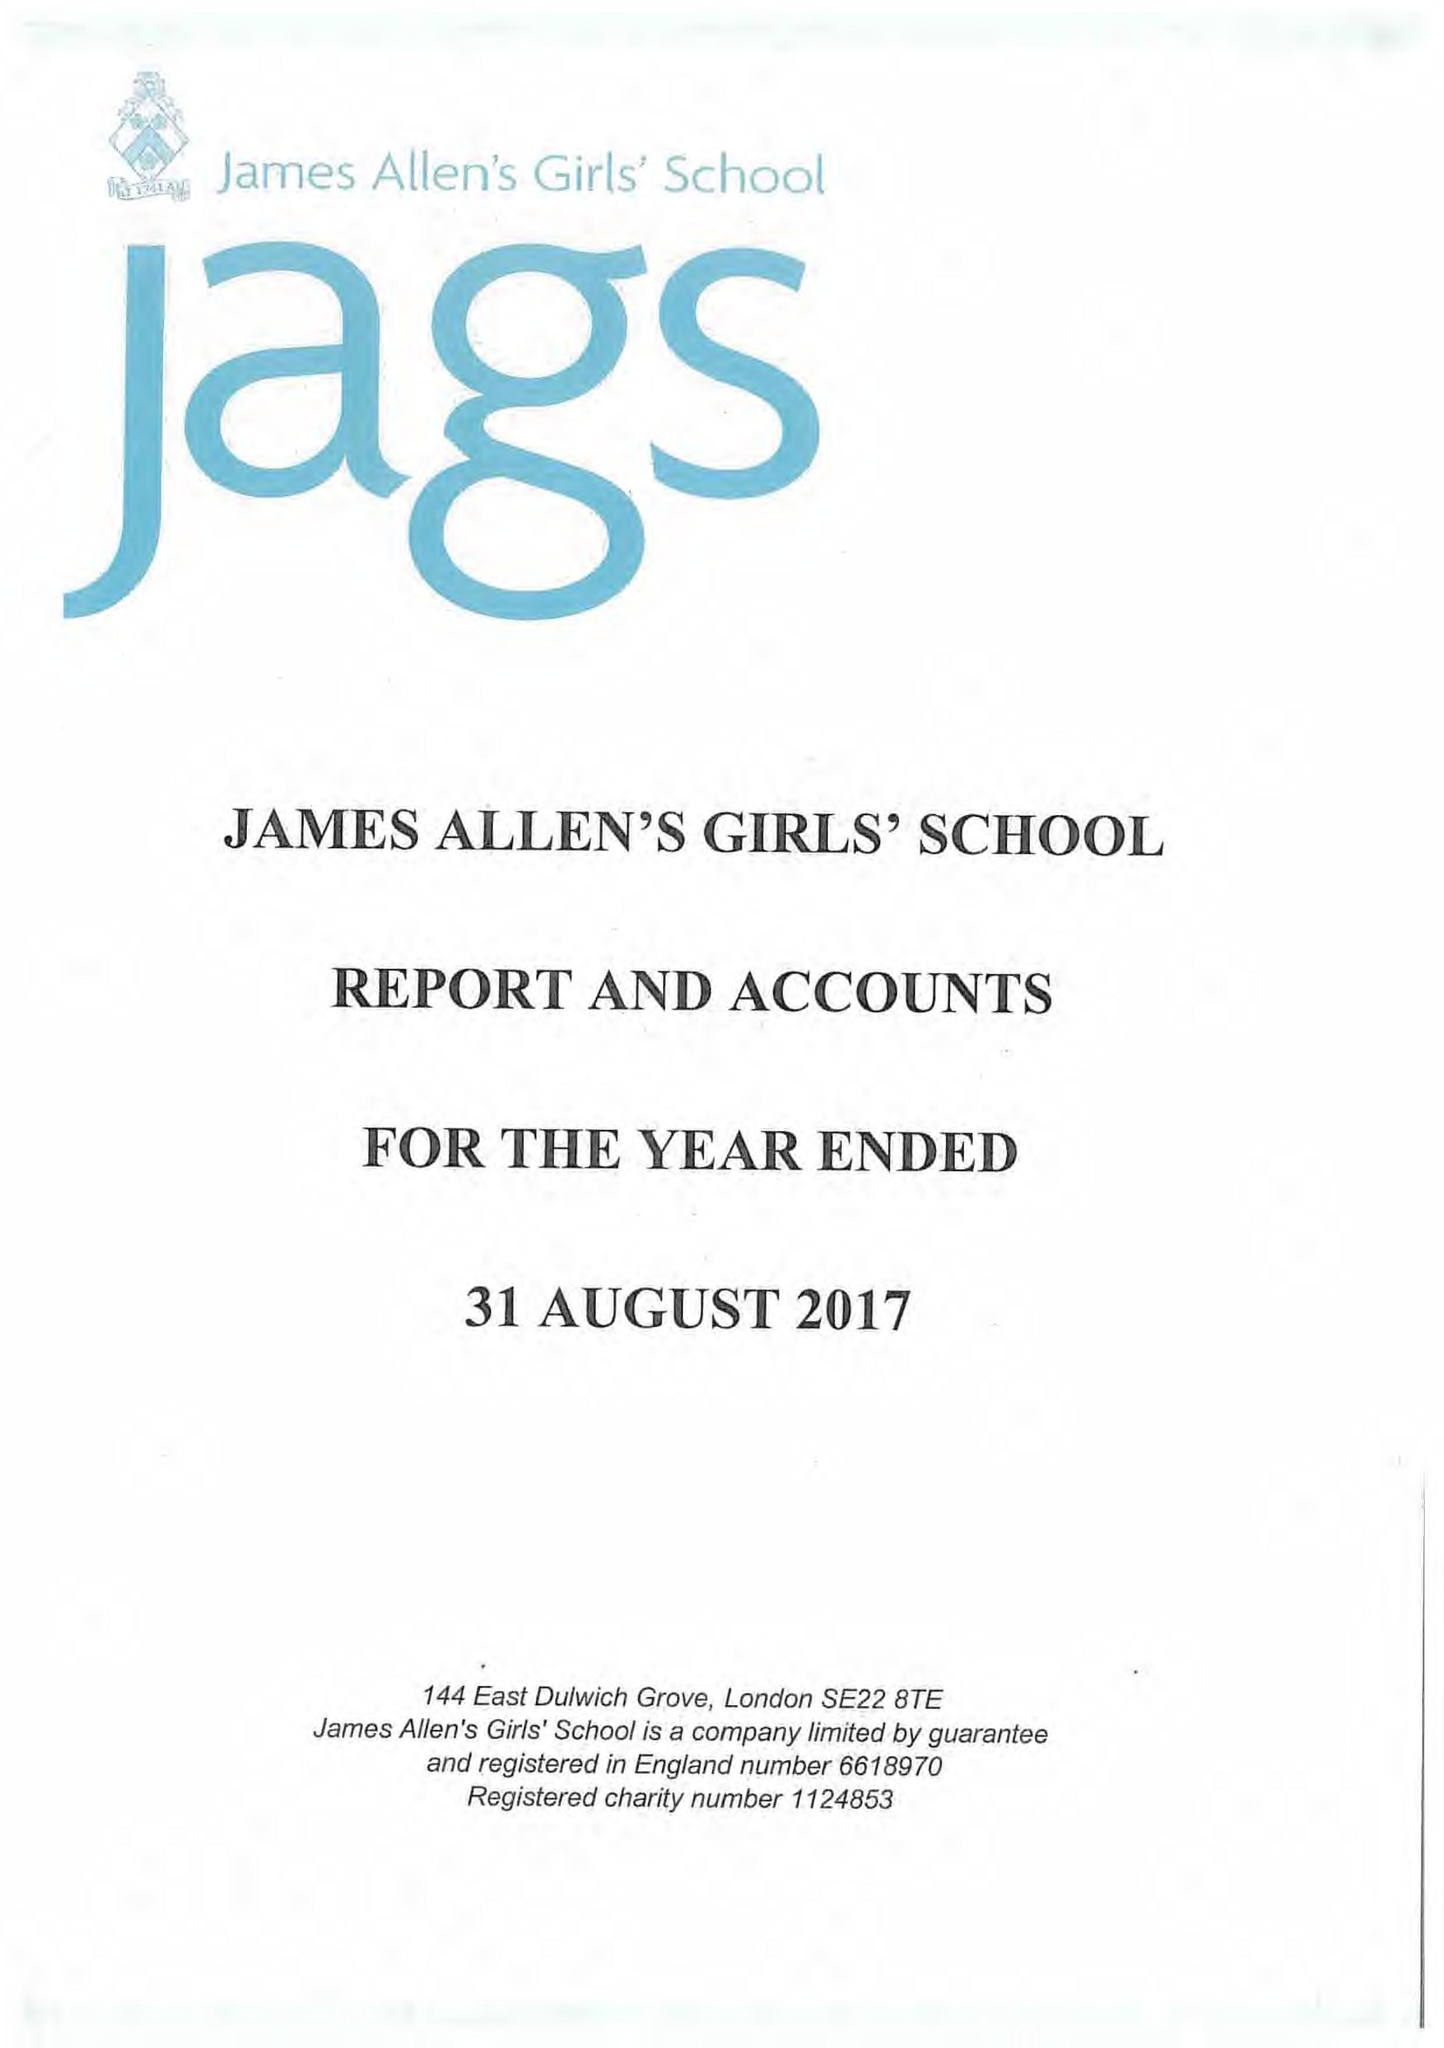What is the value for the report_date?
Answer the question using a single word or phrase. 2017-08-31 